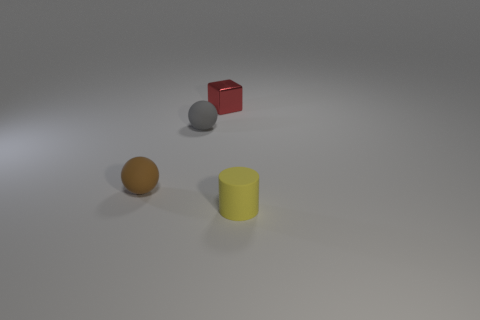Add 2 brown rubber cylinders. How many objects exist? 6 Subtract all cubes. How many objects are left? 3 Subtract 1 yellow cylinders. How many objects are left? 3 Subtract all tiny cubes. Subtract all tiny gray rubber things. How many objects are left? 2 Add 1 things. How many things are left? 5 Add 3 tiny red rubber blocks. How many tiny red rubber blocks exist? 3 